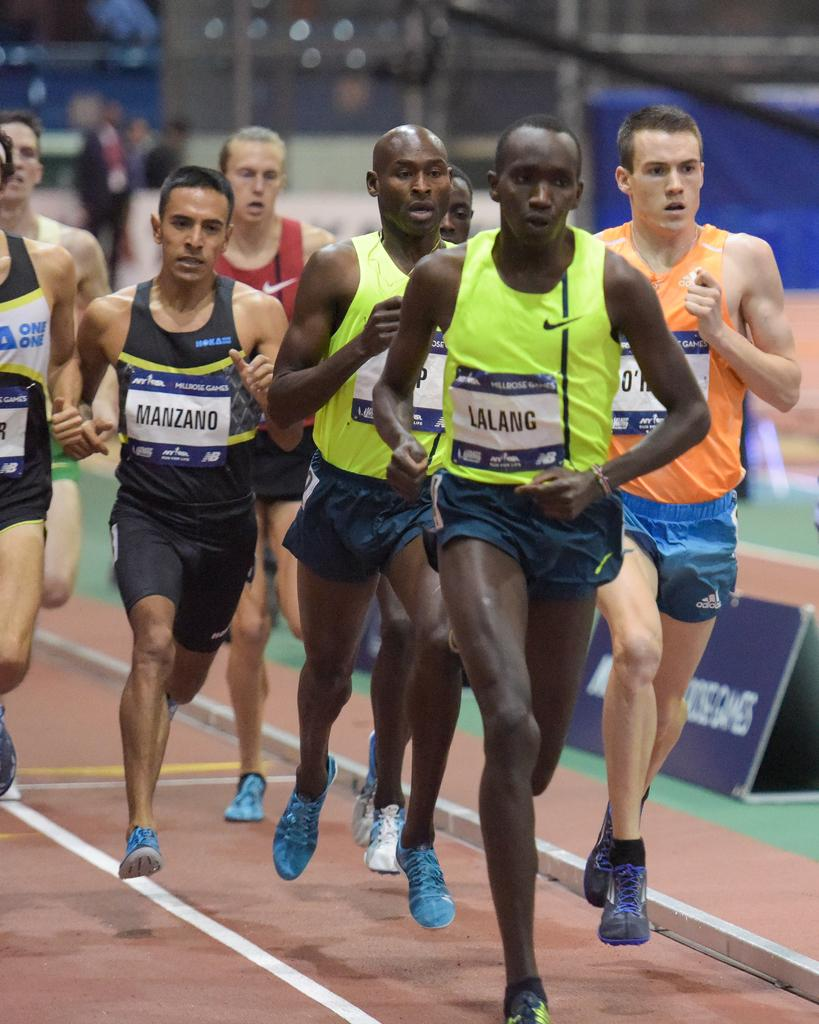<image>
Give a short and clear explanation of the subsequent image. Runners competing against each other in a race include people named Lalang and Manzano. 